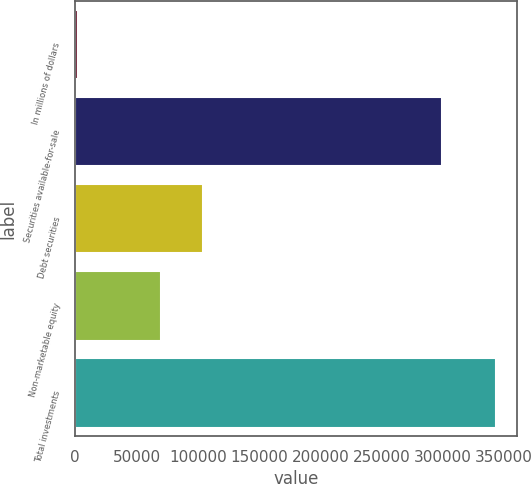<chart> <loc_0><loc_0><loc_500><loc_500><bar_chart><fcel>In millions of dollars<fcel>Securities available-for-sale<fcel>Debt securities<fcel>Non-marketable equity<fcel>Total investments<nl><fcel>2015<fcel>299136<fcel>104297<fcel>70203<fcel>342955<nl></chart> 